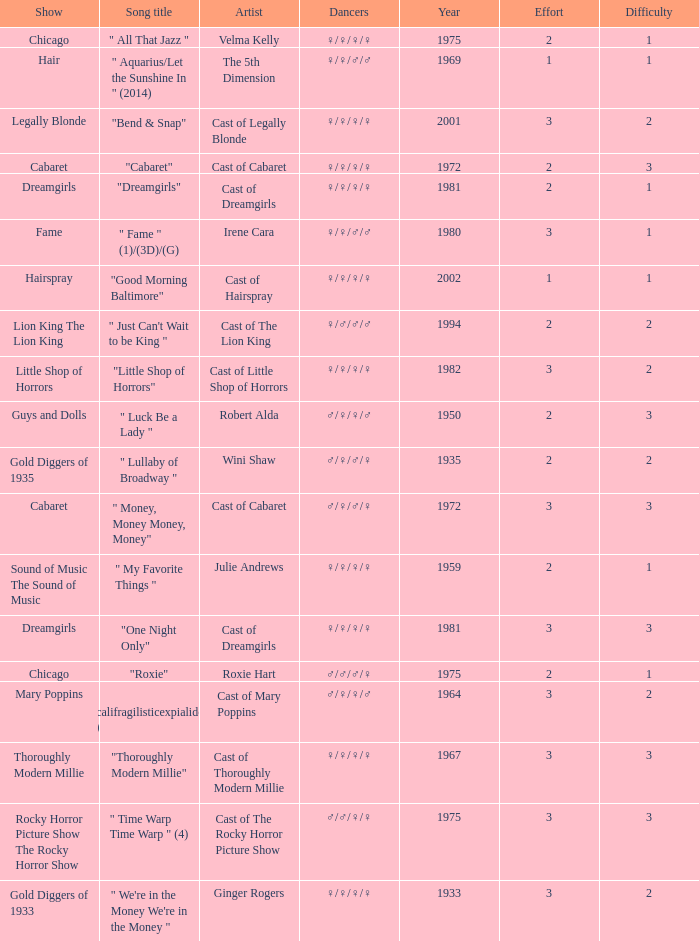What show featured the song "little shop of horrors"? Little Shop of Horrors. 